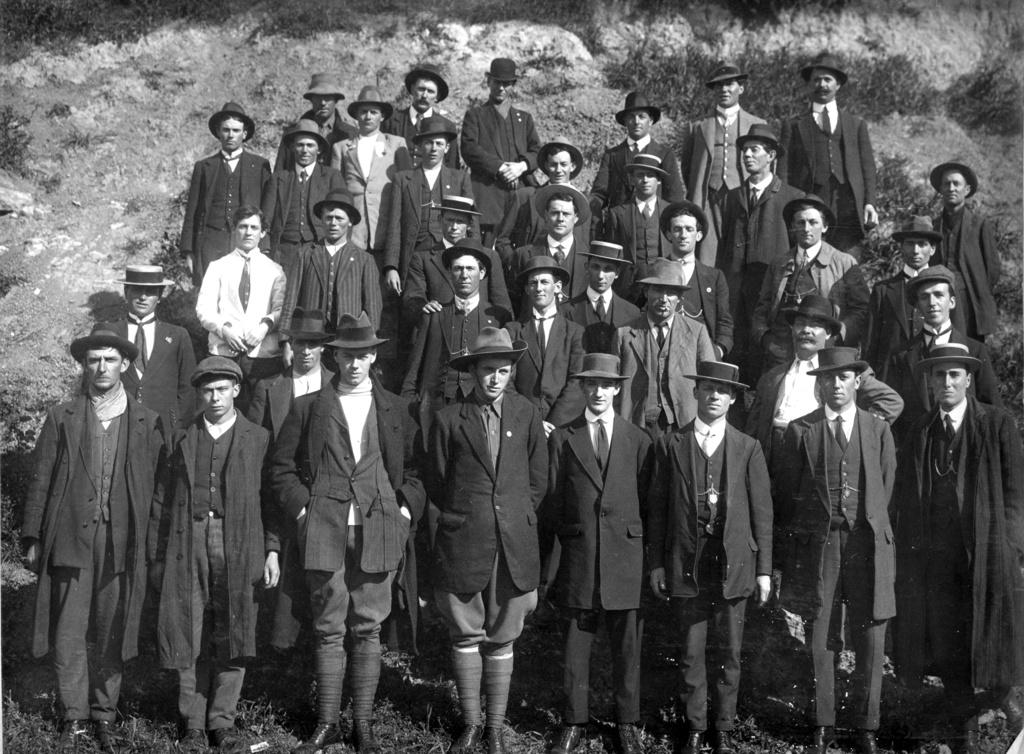What is the color scheme of the image? The image is black and white. What can be seen in the image besides the color scheme? There are people in the image. Where are the people located in the image? The people are standing on a slope area. What type of structure can be seen sparking at the end of the slope in the image? There is no structure or spark present in the image; it is a black and white image of people standing on a slope. 